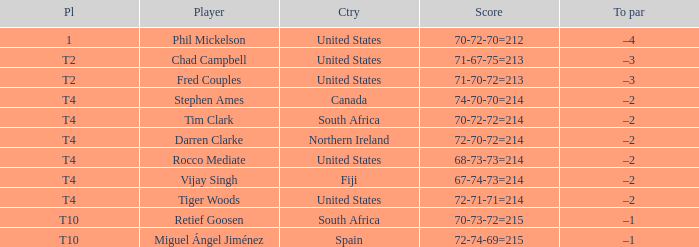Can you parse all the data within this table? {'header': ['Pl', 'Player', 'Ctry', 'Score', 'To par'], 'rows': [['1', 'Phil Mickelson', 'United States', '70-72-70=212', '–4'], ['T2', 'Chad Campbell', 'United States', '71-67-75=213', '–3'], ['T2', 'Fred Couples', 'United States', '71-70-72=213', '–3'], ['T4', 'Stephen Ames', 'Canada', '74-70-70=214', '–2'], ['T4', 'Tim Clark', 'South Africa', '70-72-72=214', '–2'], ['T4', 'Darren Clarke', 'Northern Ireland', '72-70-72=214', '–2'], ['T4', 'Rocco Mediate', 'United States', '68-73-73=214', '–2'], ['T4', 'Vijay Singh', 'Fiji', '67-74-73=214', '–2'], ['T4', 'Tiger Woods', 'United States', '72-71-71=214', '–2'], ['T10', 'Retief Goosen', 'South Africa', '70-73-72=215', '–1'], ['T10', 'Miguel Ángel Jiménez', 'Spain', '72-74-69=215', '–1']]} What country is Chad Campbell from? United States. 